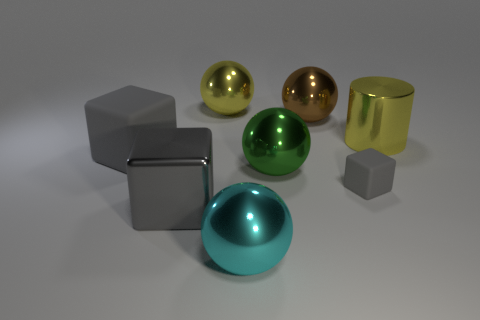How many gray cubes must be subtracted to get 1 gray cubes? 2 Subtract 1 spheres. How many spheres are left? 3 Add 2 big brown shiny things. How many objects exist? 10 Subtract all cylinders. How many objects are left? 7 Add 4 big green metal spheres. How many big green metal spheres are left? 5 Add 6 shiny cylinders. How many shiny cylinders exist? 7 Subtract 0 purple blocks. How many objects are left? 8 Subtract all large yellow shiny cylinders. Subtract all large gray blocks. How many objects are left? 5 